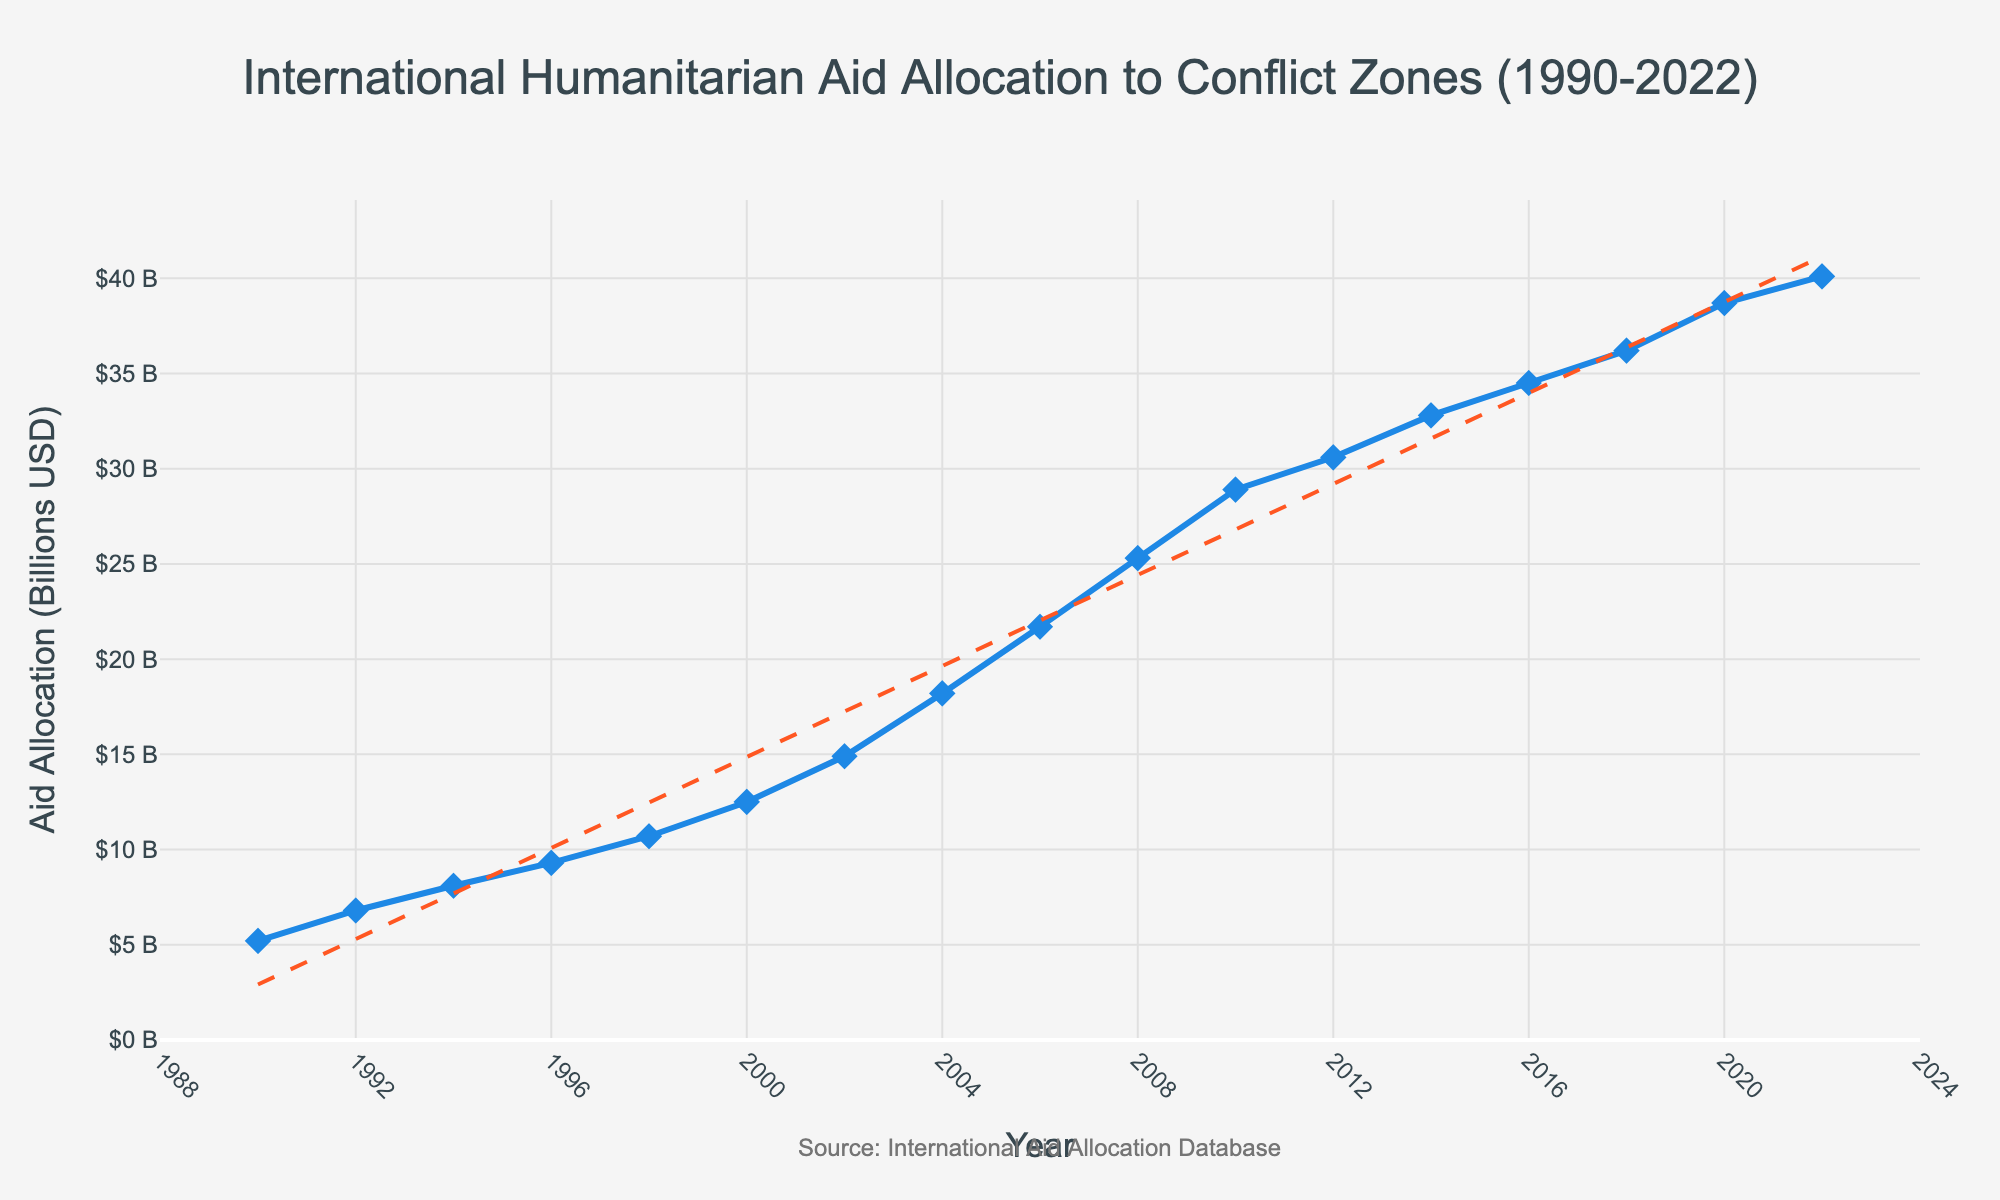What's the average aid allocation between 1990 and 2000? To find the average aid allocation between 1990 and 2000, sum up the data points for these years: 5.2 + 6.8 + 8.1 + 9.3 + 10.7 + 12.5 = 52.6. Then, divide by the number of years (6): 52.6 / 6 = 8.77
Answer: 8.77 billion USD How much did the aid allocation increase from 1990 to 2022? Subtract the 1990 allocation from the 2022 allocation: 40.1 - 5.2 = 34.9 billion USD
Answer: 34.9 billion USD Which year saw the highest aid allocation? By examining the plot, the highest aid allocation is observed at the year with the maximum y-axis value. For this plot, it is at the year 2022 with an allocation of 40.1 billion USD.
Answer: 2022 Was the aid allocation in 2006 more than double the allocation in 1990? Compare the aid allocation in 2006 (21.7 billion USD) to twice the 1990 allocation (2 * 5.2 = 10.4 billion USD). Since 21.7 > 10.4, the answer is yes.
Answer: Yes Between which consecutive years was the highest increase in aid allocation observed? Calculate the differences between consecutive years and find the maximum. Differences are: 
1992-1990: 6.8-5.2=1.6,
1994-1992: 8.1-6.8=1.3,
1996-1994: 9.3-8.1=1.2,
1998-1996: 10.7-9.3=1.4,
2000-1998: 12.5-10.7=1.8,
2002-2000: 14.9-12.5=2.4,
2004-2002: 18.2-14.9=3.3,
2006-2004: 21.7-18.2=3.5,
2008-2006: 25.3-21.7=3.6,
2010-2008: 28.9-25.3=3.6,
2012-2010: 30.6-28.9=1.7,
2014-2012: 32.8-30.6=2.2,
2016-2014: 34.5-32.8=1.7,
2018-2016: 36.2-34.5=1.7,
2020-2018: 38.7-36.2=2.5,
2022-2020: 40.1-38.7=1.4. The highest increase is 3.6 billion USD between 2008 and 2010.
Answer: 2008 to 2010 What is the general trend in aid allocation from 1990 to 2022? Observing the line chart, the overall trend is an upward trend, indicating a continuous increase in aid allocation over time. This trend is supported by the orange dashed-line trend line in the chart.
Answer: Upward In which period did the aid allocation exceed 30 billion USD for the first time? Scan the y-axis values to see when the allocation first crosses the 30 billion USD mark. It occurs between 2010 (28.9 billion USD) and 2012 (30.6 billion USD). Thus, 2012 is the first year the aid allocation exceeded 30 billion USD.
Answer: 2012 What's the average annual increase in aid allocation from 2000 to 2022? First, calculate the total increase from 2000 to 2022: 40.1 - 12.5 = 27.6 billion USD. There are 22 years from 2000 to 2022, so divide the total increase by the number of years: 27.6 / 22 = 1.2545 billion USD per year.
Answer: 1.25 billion USD per year 